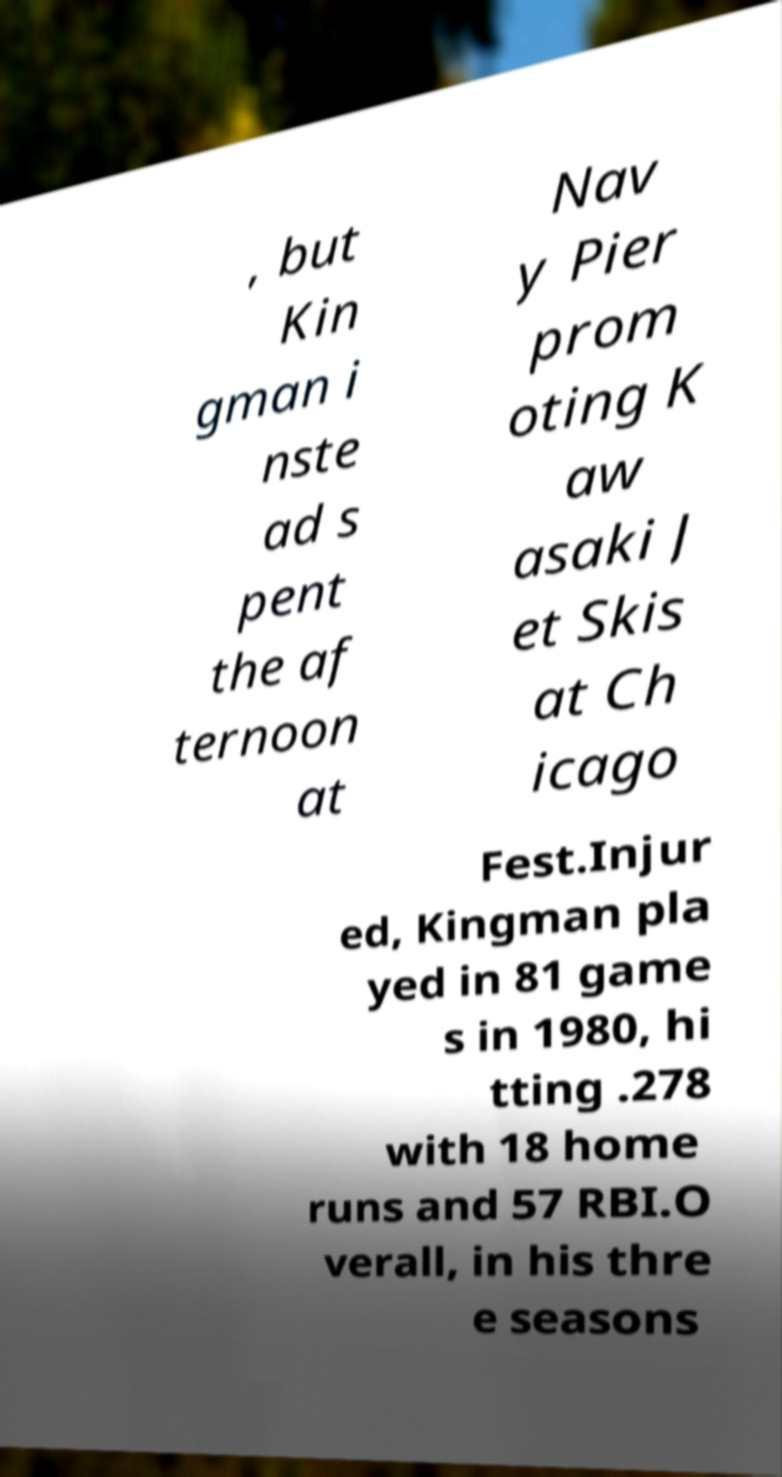Can you accurately transcribe the text from the provided image for me? , but Kin gman i nste ad s pent the af ternoon at Nav y Pier prom oting K aw asaki J et Skis at Ch icago Fest.Injur ed, Kingman pla yed in 81 game s in 1980, hi tting .278 with 18 home runs and 57 RBI.O verall, in his thre e seasons 